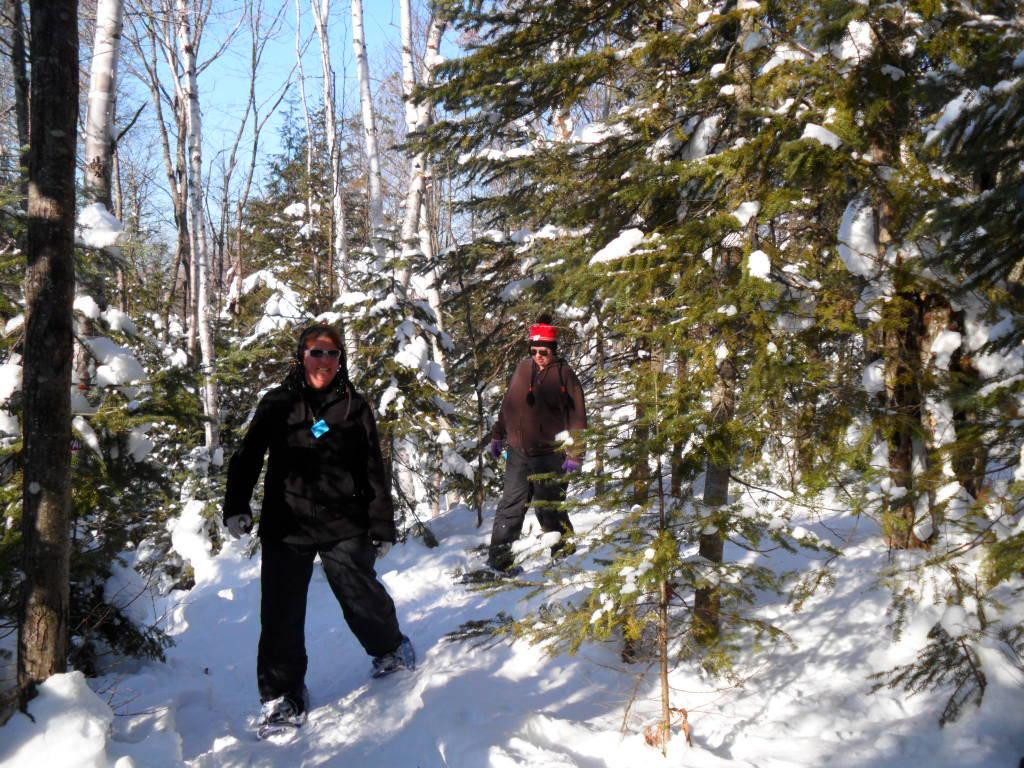What are the two people in the image doing? The two people in the image are walking. What type of natural environment can be seen in the image? There are trees in the image. How is the weather in the image? Snow is present in the image, and the trees are partially covered with snow, indicating a snowy environment. What type of horn can be heard in the image? There is no horn present in the image, and therefore no sound can be heard. 